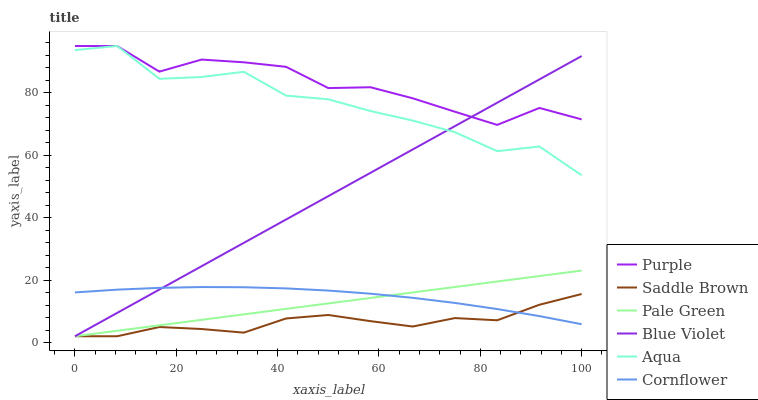Does Saddle Brown have the minimum area under the curve?
Answer yes or no. Yes. Does Purple have the maximum area under the curve?
Answer yes or no. Yes. Does Aqua have the minimum area under the curve?
Answer yes or no. No. Does Aqua have the maximum area under the curve?
Answer yes or no. No. Is Pale Green the smoothest?
Answer yes or no. Yes. Is Aqua the roughest?
Answer yes or no. Yes. Is Purple the smoothest?
Answer yes or no. No. Is Purple the roughest?
Answer yes or no. No. Does Pale Green have the lowest value?
Answer yes or no. Yes. Does Aqua have the lowest value?
Answer yes or no. No. Does Aqua have the highest value?
Answer yes or no. Yes. Does Pale Green have the highest value?
Answer yes or no. No. Is Cornflower less than Aqua?
Answer yes or no. Yes. Is Purple greater than Saddle Brown?
Answer yes or no. Yes. Does Saddle Brown intersect Blue Violet?
Answer yes or no. Yes. Is Saddle Brown less than Blue Violet?
Answer yes or no. No. Is Saddle Brown greater than Blue Violet?
Answer yes or no. No. Does Cornflower intersect Aqua?
Answer yes or no. No. 